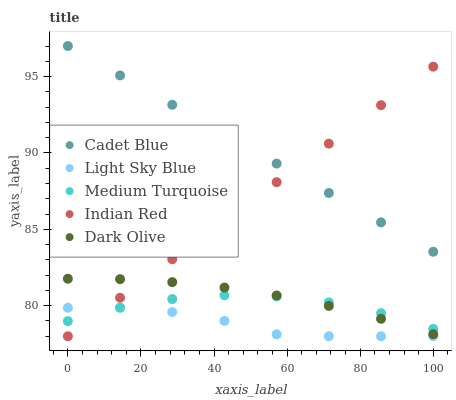Does Light Sky Blue have the minimum area under the curve?
Answer yes or no. Yes. Does Cadet Blue have the maximum area under the curve?
Answer yes or no. Yes. Does Dark Olive have the minimum area under the curve?
Answer yes or no. No. Does Dark Olive have the maximum area under the curve?
Answer yes or no. No. Is Cadet Blue the smoothest?
Answer yes or no. Yes. Is Medium Turquoise the roughest?
Answer yes or no. Yes. Is Dark Olive the smoothest?
Answer yes or no. No. Is Dark Olive the roughest?
Answer yes or no. No. Does Indian Red have the lowest value?
Answer yes or no. Yes. Does Dark Olive have the lowest value?
Answer yes or no. No. Does Cadet Blue have the highest value?
Answer yes or no. Yes. Does Dark Olive have the highest value?
Answer yes or no. No. Is Medium Turquoise less than Cadet Blue?
Answer yes or no. Yes. Is Cadet Blue greater than Dark Olive?
Answer yes or no. Yes. Does Medium Turquoise intersect Indian Red?
Answer yes or no. Yes. Is Medium Turquoise less than Indian Red?
Answer yes or no. No. Is Medium Turquoise greater than Indian Red?
Answer yes or no. No. Does Medium Turquoise intersect Cadet Blue?
Answer yes or no. No. 